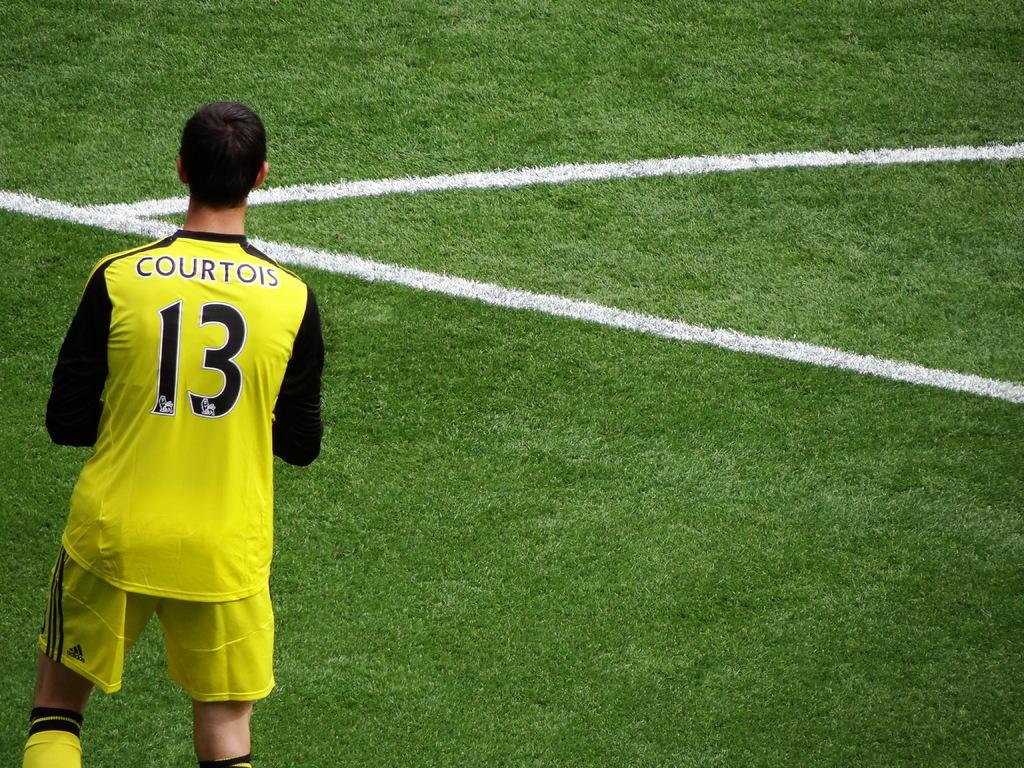<image>
Present a compact description of the photo's key features. A soccer player has the name Courtois on the back of his shirt. 